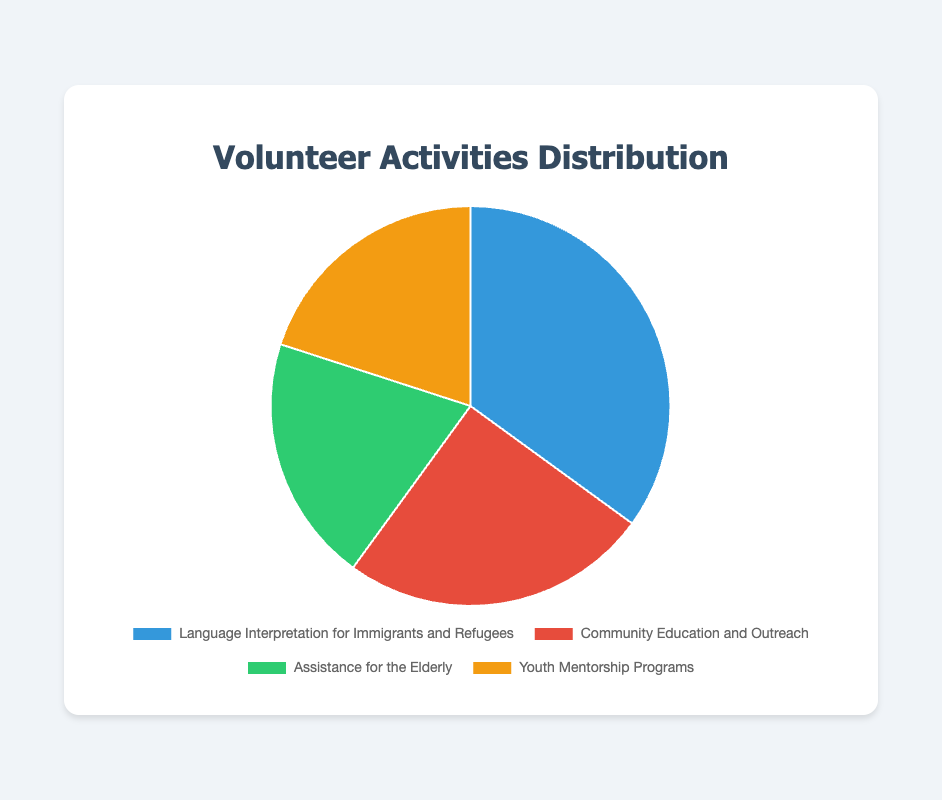What percentage of volunteer activities are dedicated to Community Education and Outreach? Locate the section of the pie chart that corresponds to Community Education and Outreach and read the percentage label.
Answer: 25% Which area of service has the highest percentage of volunteer activities? Compare the percentage labels of all pie chart sections to identify the area with the highest value.
Answer: Language Interpretation for Immigrants and Refugees How does the percentage of Youth Mentorship Programs compare to Assistance for the Elderly? Read the percentages for Youth Mentorship Programs and Assistance for the Elderly and compare them. They both have 20%.
Answer: Equal What is the combined percentage of volunteer activities for Assistance for the Elderly and Youth Mentorship Programs? Add the percentages of Assistance for the Elderly (20%) and Youth Mentorship Programs (20%).
Answer: 40% What is the difference in percentage between the area with the highest volunteer activity and Community Education and Outreach? Subtract the percentage of Community Education and Outreach (25%) from the highest percentage, Language Interpretation for Immigrants and Refugees (35%).
Answer: 10% Which area of service is represented by the red section of the pie chart? Identify the color red on the pie chart and look at the corresponding label.
Answer: Community Education and Outreach What percentage of volunteer activities are not dedicated to Language Interpretation for Immigrants and Refugees? Subtract the percentage of Language Interpretation for Immigrants and Refugees (35%) from 100%.
Answer: 65% How do the percentages of Community Education and Outreach and Language Interpretation for Immigrants and Refugees together compare to the total percentage of other activities? Add the percentages of Community Education and Outreach (25%) and Language Interpretation (35%) and compare to the sum of other activities (100% - 60%).
Answer: Equal If the chart was updated and Youth Mentorship Programs increased to 30%, how would this affect the combined percentage of all other services? Increase the Youth Mentorship percentage to 30% and subtract this from 100%. The rest of the percentages would need to be readjusted proportionally to maintain the new combined total.
Answer: 70% What's the sum of the percentages of all the volunteer activities? Add up all the percentages shown on the pie chart: 35 + 25 + 20 + 20.
Answer: 100% 